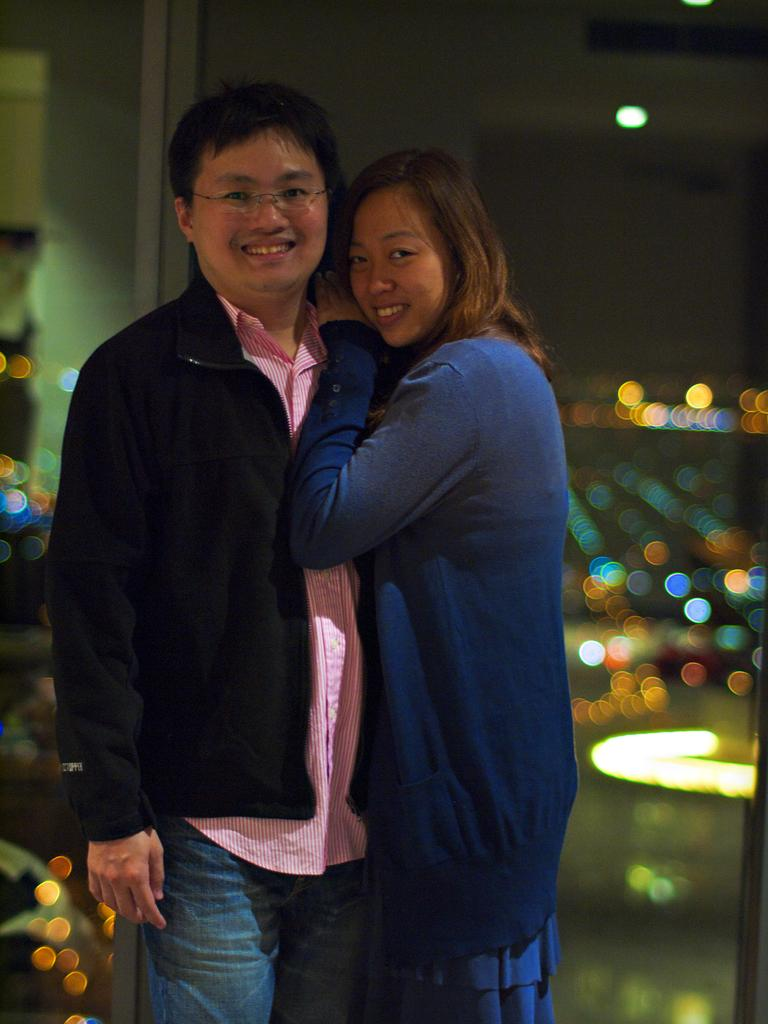How many people are in the image? There are two people in the image. What are the people doing in the image? The people are standing in front of a glass window and looking and smiling at someone. What can be seen behind the people in the image? There are blurry lights in the background of the image. What health benefits can be gained from the crook visible in the image? There is no crook present in the image, so it is not possible to discuss any health benefits associated with it. --- Facts: 1. There is a person holding a book in the image. 2. The book has a blue cover. 3. The person is sitting on a chair. 4. There is a table next to the chair. 5. The table has a cup of coffee on it. Absurd Topics: parrot, volcano, dance Conversation: What is the person in the image holding? The person is holding a book in the image. What color is the book's cover? The book has a blue cover. What is the person sitting on in the image? The person is sitting on a chair. What is located next to the chair in the image? There is a table next to the chair. What can be seen on the table in the image? There is a cup of coffee on the table. Reasoning: Let's think step by step in order to produce the conversation. We start by identifying the main subject in the image, which is the person holding a book. Then, we describe the book's characteristics, such as its blue cover. Next, we mention the person's position and the presence of a chair. Finally, we describe the table and its contents, which include a cup of coffee. Absurd Question/Answer: Can you tell me how many parrots are sitting on the volcano in the image? There are no parrots or volcanoes present in the image; it features a person holding a book and sitting on a chair with a table and a cup of coffee nearby. --- Facts: 1. There is a dog in the image. 2. The dog is lying down. 3. The dog has a red collar. 4. There is a person standing next to the dog. 5. The person is holding a leash. Absurd Topics: spaceship, rainbow, concert Conversation: What type of animal is in the image? There is a dog in the image. What is the dog doing in the image? The dog is lying down. What can be seen around the dog's neck in the image? The dog has a red collar. Who is standing next to the dog in the image? There is a person standing next to the dog. What is the person holding in the image? The person is 